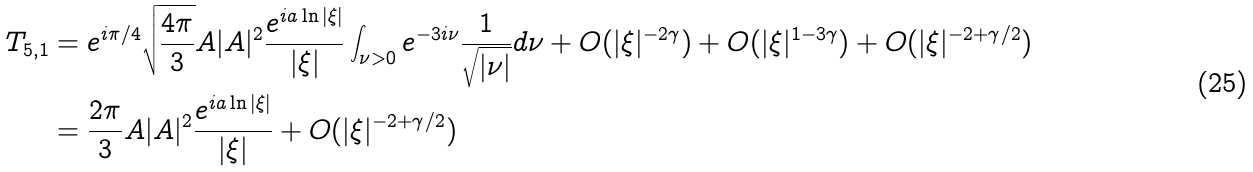Convert formula to latex. <formula><loc_0><loc_0><loc_500><loc_500>T _ { 5 , 1 } & = e ^ { i \pi / 4 } \sqrt { \frac { 4 \pi } { 3 } } A | A | ^ { 2 } \frac { e ^ { i a \ln | \xi | } } { | \xi | } \int _ { \nu > 0 } e ^ { - 3 i \nu } \frac { 1 } { \sqrt { | \nu | } } d \nu + O ( | \xi | ^ { - 2 \gamma } ) + O ( | \xi | ^ { 1 - 3 \gamma } ) + O ( | \xi | ^ { - 2 + \gamma / 2 } ) \\ & = \frac { 2 \pi } { 3 } A | A | ^ { 2 } \frac { e ^ { i a \ln | \xi | } } { | \xi | } + O ( | \xi | ^ { - 2 + \gamma / 2 } )</formula> 